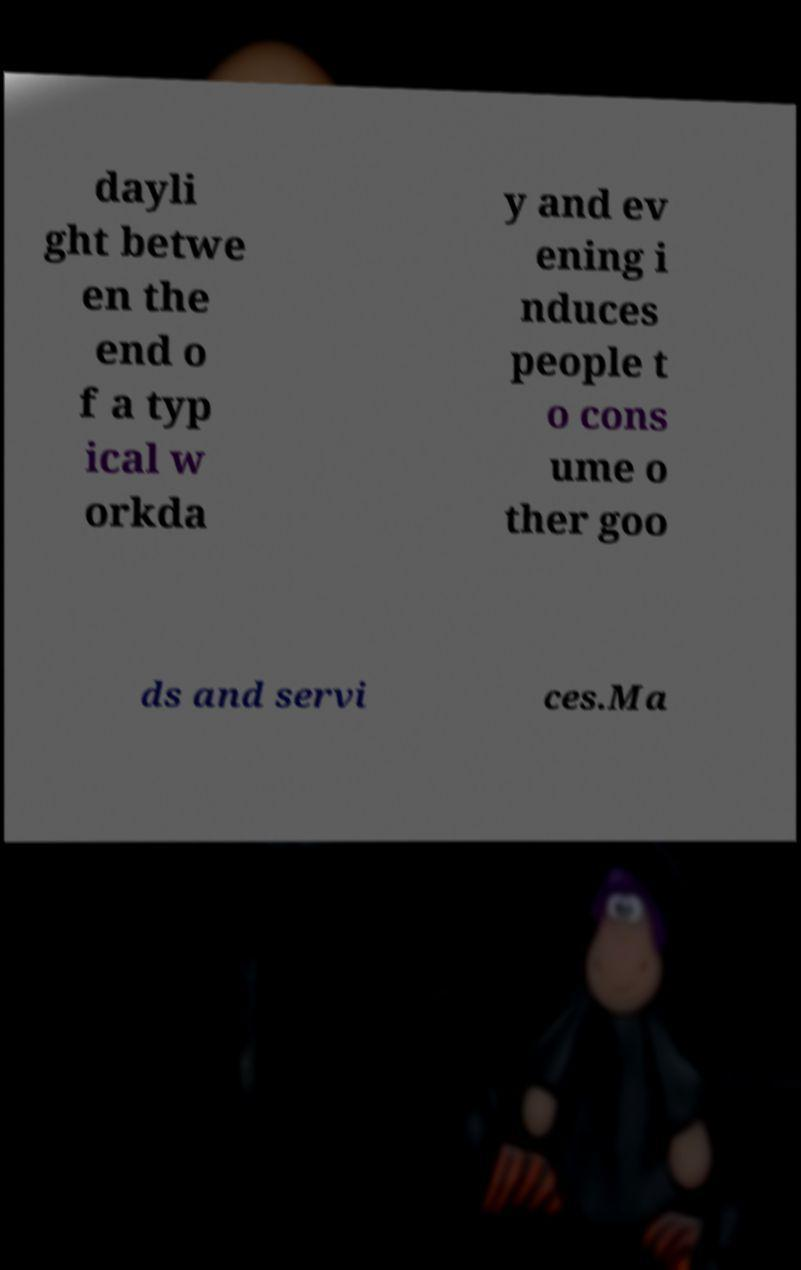Please read and relay the text visible in this image. What does it say? dayli ght betwe en the end o f a typ ical w orkda y and ev ening i nduces people t o cons ume o ther goo ds and servi ces.Ma 